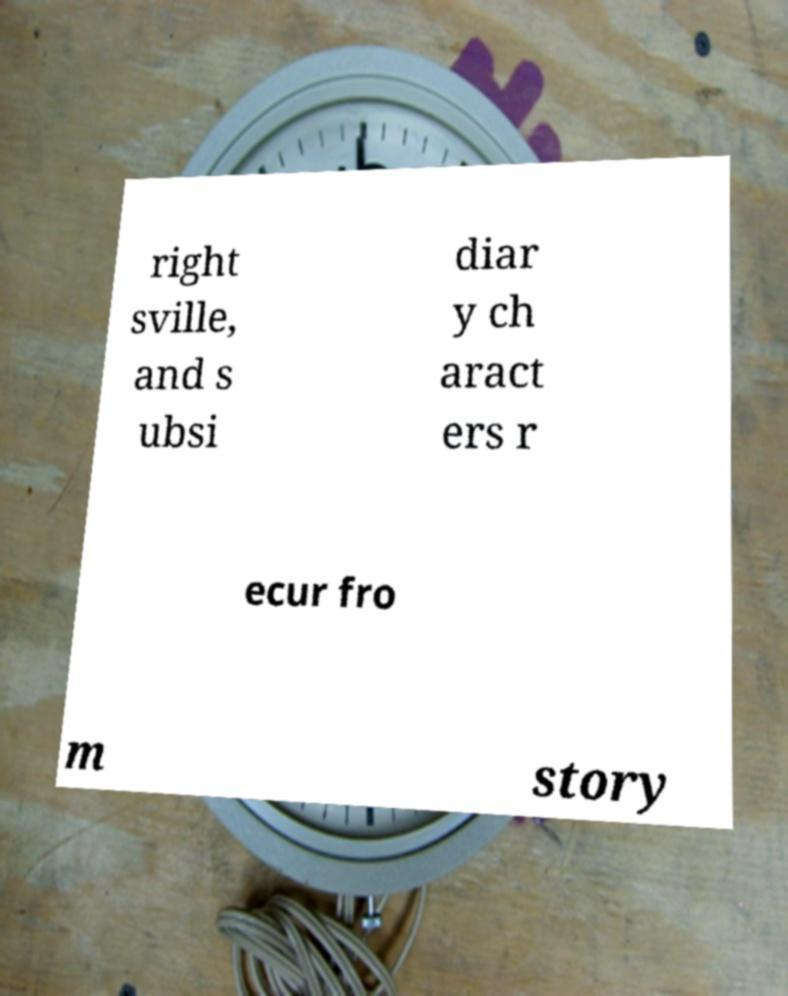Can you read and provide the text displayed in the image?This photo seems to have some interesting text. Can you extract and type it out for me? right sville, and s ubsi diar y ch aract ers r ecur fro m story 